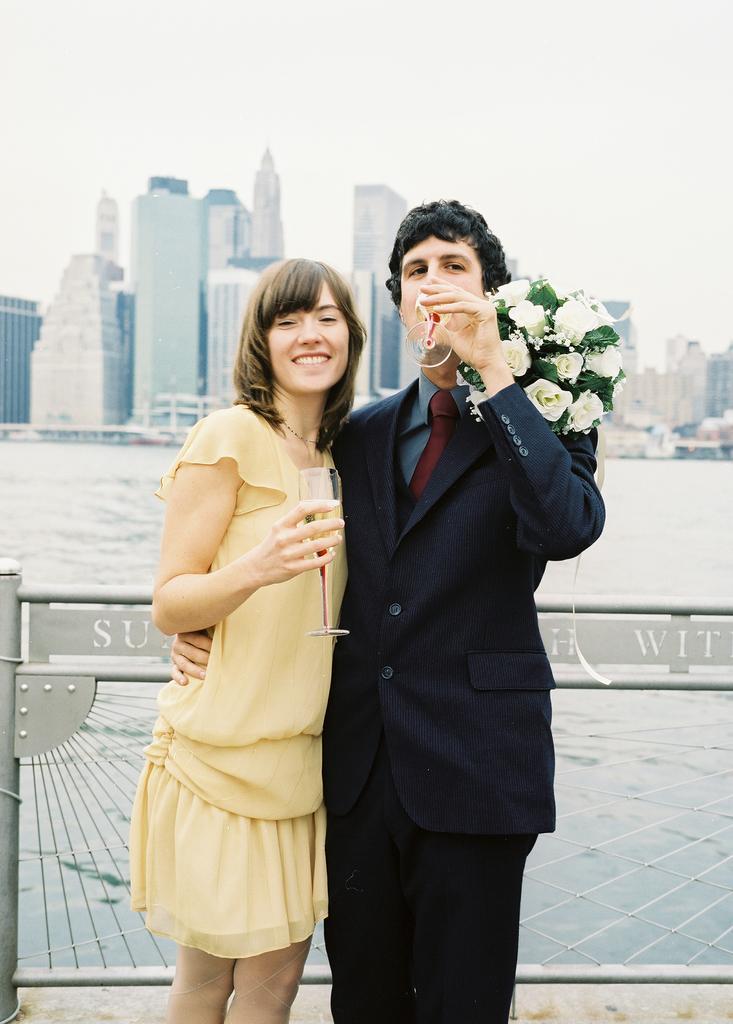Describe this image in one or two sentences. In the picture we can see man wearing blue color suit and woman wearing yellow color dress standing and hugging each other, holding glasses in their hands and man also holding flower bouquet and in the background there is water, there are some buildings and clear sky. 